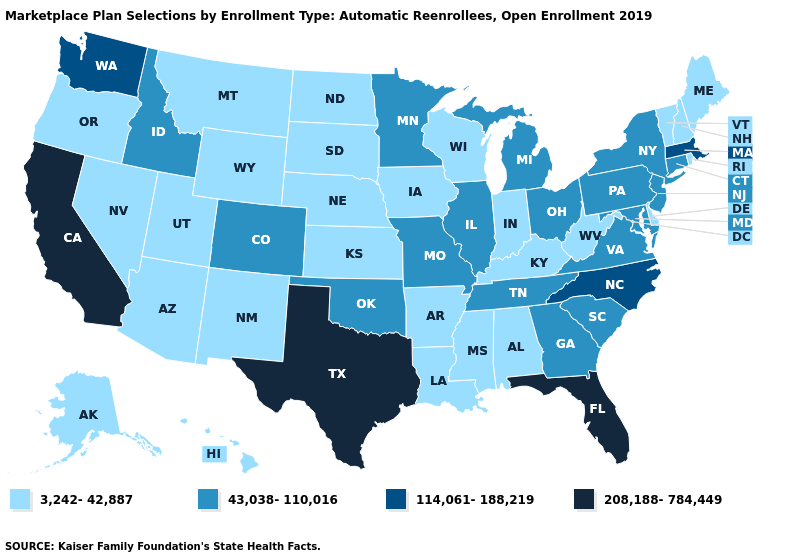Name the states that have a value in the range 43,038-110,016?
Answer briefly. Colorado, Connecticut, Georgia, Idaho, Illinois, Maryland, Michigan, Minnesota, Missouri, New Jersey, New York, Ohio, Oklahoma, Pennsylvania, South Carolina, Tennessee, Virginia. What is the value of Arkansas?
Write a very short answer. 3,242-42,887. Does Oregon have the highest value in the USA?
Concise answer only. No. Among the states that border Maine , which have the highest value?
Short answer required. New Hampshire. Name the states that have a value in the range 43,038-110,016?
Write a very short answer. Colorado, Connecticut, Georgia, Idaho, Illinois, Maryland, Michigan, Minnesota, Missouri, New Jersey, New York, Ohio, Oklahoma, Pennsylvania, South Carolina, Tennessee, Virginia. Name the states that have a value in the range 114,061-188,219?
Concise answer only. Massachusetts, North Carolina, Washington. Name the states that have a value in the range 114,061-188,219?
Concise answer only. Massachusetts, North Carolina, Washington. Which states hav the highest value in the West?
Answer briefly. California. Among the states that border Georgia , which have the highest value?
Write a very short answer. Florida. What is the value of Maryland?
Concise answer only. 43,038-110,016. Among the states that border Nevada , which have the highest value?
Quick response, please. California. Name the states that have a value in the range 208,188-784,449?
Answer briefly. California, Florida, Texas. What is the lowest value in states that border Utah?
Give a very brief answer. 3,242-42,887. What is the value of Minnesota?
Keep it brief. 43,038-110,016. Does Louisiana have a lower value than North Dakota?
Short answer required. No. 